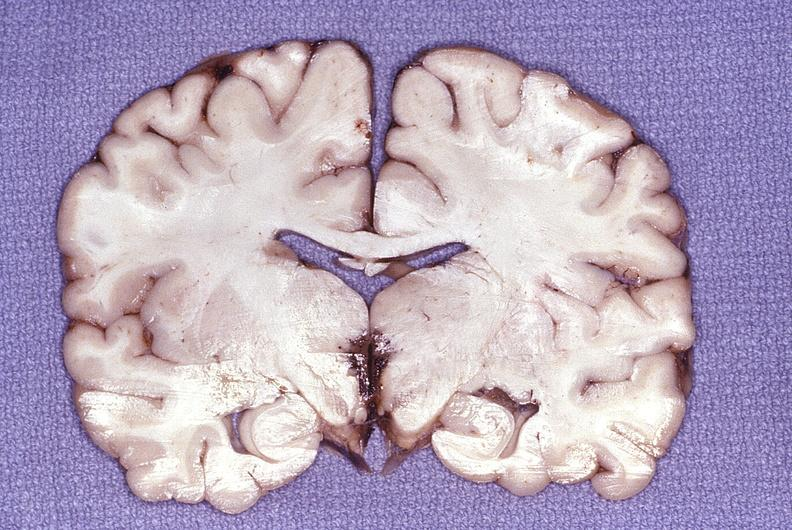does this image show wernicke 's encephalopathy?
Answer the question using a single word or phrase. Yes 